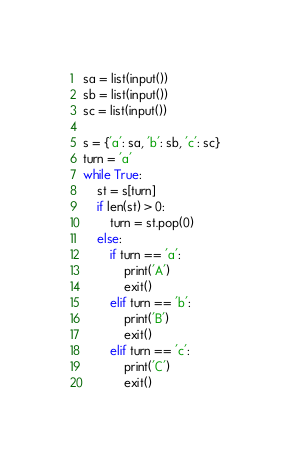<code> <loc_0><loc_0><loc_500><loc_500><_Python_>sa = list(input())
sb = list(input())
sc = list(input())

s = {'a': sa, 'b': sb, 'c': sc}
turn = 'a'
while True:
    st = s[turn]
    if len(st) > 0:
        turn = st.pop(0)
    else:
        if turn == 'a':
            print('A')
            exit()
        elif turn == 'b':
            print('B')
            exit()
        elif turn == 'c':
            print('C')
            exit()
</code> 